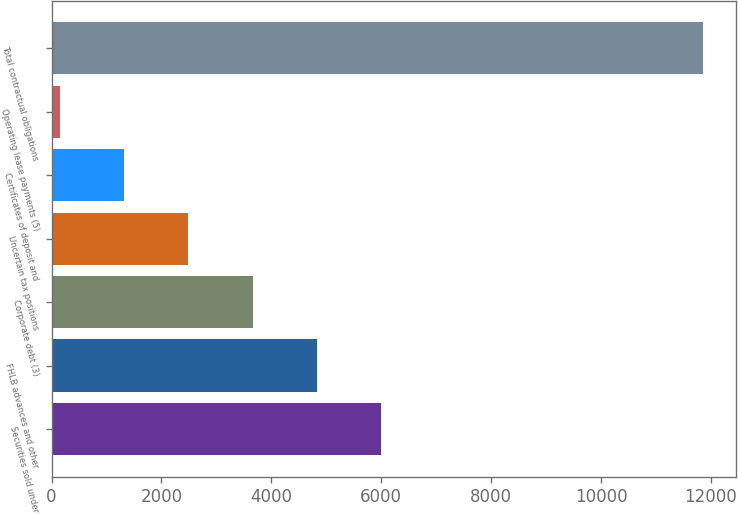Convert chart. <chart><loc_0><loc_0><loc_500><loc_500><bar_chart><fcel>Securities sold under<fcel>FHLB advances and other<fcel>Corporate debt (3)<fcel>Uncertain tax positions<fcel>Certificates of deposit and<fcel>Operating lease payments (5)<fcel>Total contractual obligations<nl><fcel>6003.85<fcel>4832.08<fcel>3660.31<fcel>2488.54<fcel>1316.77<fcel>145<fcel>11862.7<nl></chart> 